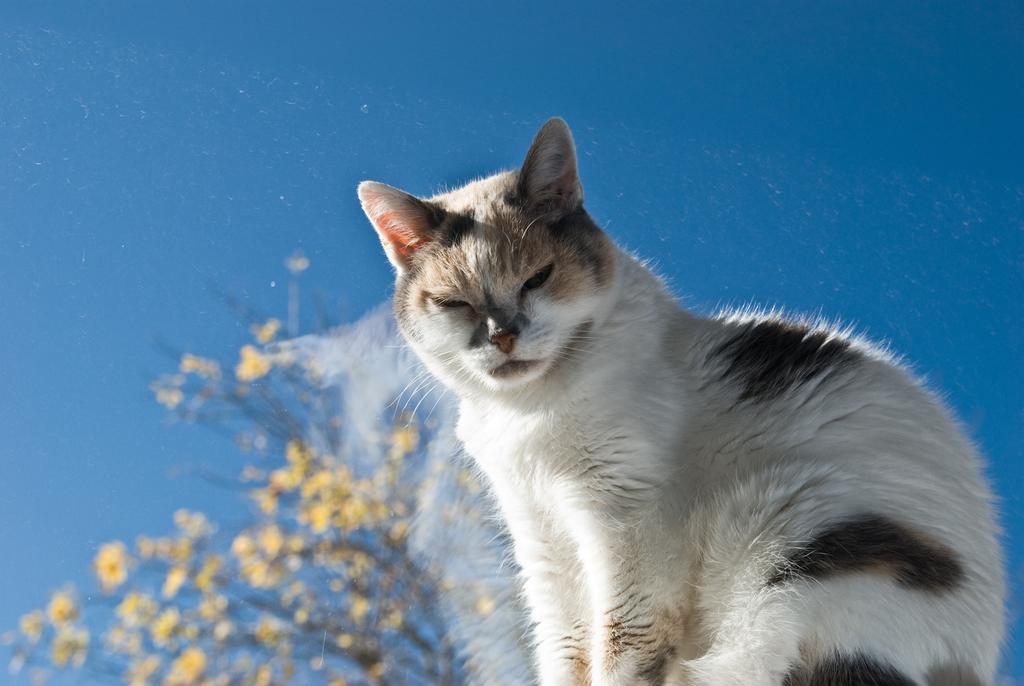Could you give a brief overview of what you see in this image? In this image, there is a cat on the blue background. There are some flowers in the bottom left of the image. 